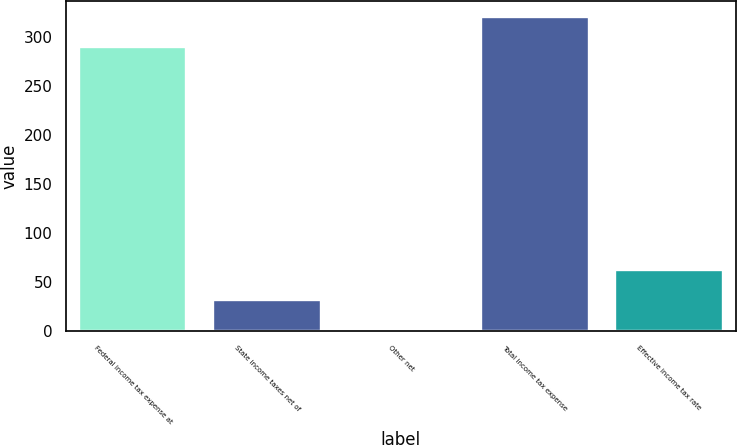Convert chart to OTSL. <chart><loc_0><loc_0><loc_500><loc_500><bar_chart><fcel>Federal income tax expense at<fcel>State income taxes net of<fcel>Other net<fcel>Total income tax expense<fcel>Effective income tax rate<nl><fcel>289.1<fcel>31.87<fcel>1<fcel>319.97<fcel>62.74<nl></chart> 